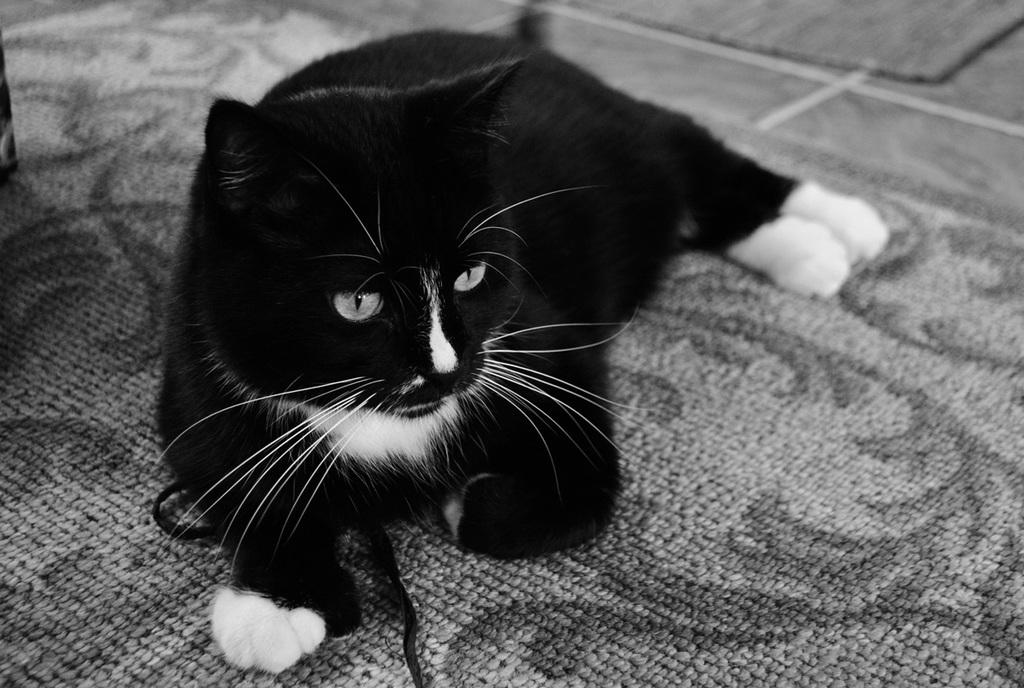What is the color scheme of the image? The image is black and white. What animal can be seen in the image? There is a cat in the image. Where is the cat located in the image? The cat is on a carpet. How many mice are hiding under the carpet in the image? There are no mice present in the image; it only features a cat on a carpet. What type of bulb is illuminating the cat in the image? There is no bulb visible in the image, and the cat is not being illuminated by any light source. 